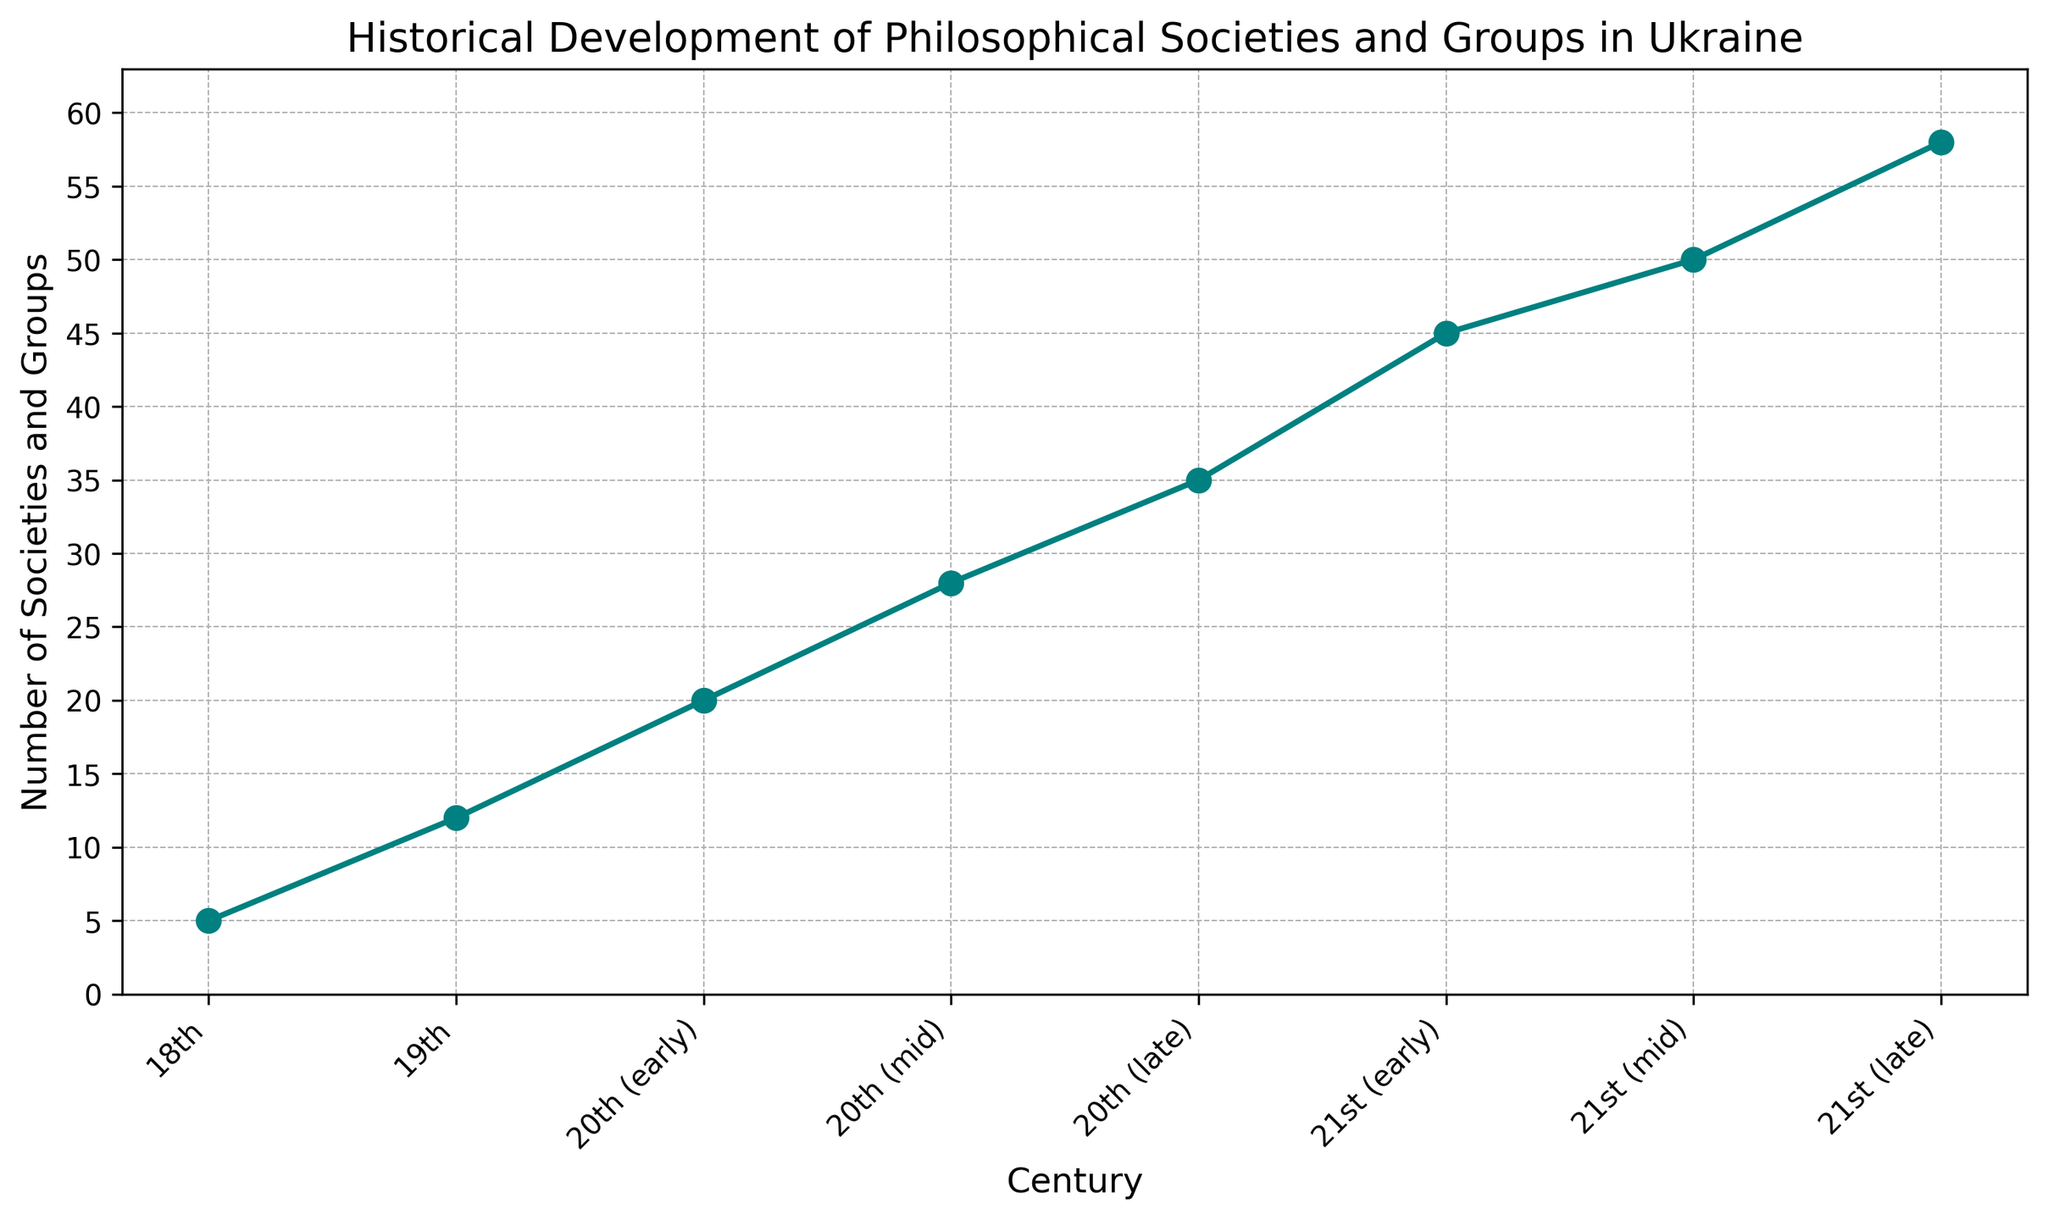How many more philosophical societies and groups were there in the 21st (early) century compared to the 18th century? First, find the number of societies in the 21st (early) century, which is 45. Then, find the number in the 18th century, which is 5. Subtract 5 from 45 to get the difference.
Answer: 40 Between which two consecutive centuries did the number of philosophical societies and groups increase the most? Calculate the difference in the number of societies between each consecutive pair of centuries: 
  
   - 18th to 19th: 12 - 5 = 7
   - 19th to 20th (early): 20 - 12 = 8
   - 20th (early) to 20th (mid): 28 - 20 = 8
   - 20th (mid) to 20th (late): 35 - 28 = 7
   - 20th (late) to 21st (early): 45 - 35 = 10
   - 21st (early) to 21st (mid): 50 - 45 = 5
   - 21st (mid) to 21st (late): 58 - 50 = 8
  
  The largest increase of 10 occurs from the 20th (late) to the 21st (early) century.
Answer: 20th (late) to 21st (early) What is the average number of philosophical societies and groups from the 18th century to the 21st (late) century? Sum the number of societies across all the centuries, which is 5 + 12 + 20 + 28 + 35 + 45 + 50 + 58 = 253. Then divide by the number of centuries, which is 8.
Answer: 31.625 How does the number of philosophical societies and groups in the 19th century compare to the 20th (early) century? In the 19th century, the number of societies is 12, and in the 20th (early) century, it is 20. Compare the two by finding the difference, 20 - 12 = 8.
Answer: 8 fewer in the 19th century Which century saw the smallest increase in the number of philosophical societies and groups compared to the previous century? Calculate the increases for each consecutive pair: 
  
   - 18th to 19th: 12 - 5 = 7
   - 19th to 20th (early): 20 - 12 = 8
   - 20th (early) to 20th (mid): 28 - 20 = 8
   - 20th (mid) to 20th (late): 35 - 28 = 7
   - 20th (late) to 21st (early): 45 - 35 = 10
   - 21st (early) to 21st (mid): 50 - 45 = 5
   - 21st (mid) to 21st (late): 58 - 50 = 8
  
  The smallest increase of 5 occurs from the 21st (early) to the 21st (mid) century.
Answer: 21st (early) to 21st (mid) What trends can you observe in the number of philosophical societies and groups in Ukraine over time? The chart shows a general upward trend with periodic increases in the number of societies and groups in every subsequent century. This trend accelerates significantly in the 20th and 21st centuries, with each following interval showing notable increases.
Answer: Upward trend, accelerating in the 20th and 21st centuries Among the data points, which century had the highest number of philosophical societies and groups and what is that number? Locate the highest point on the chart, at the 21st (late) century, showing 58 societies and groups.
Answer: 21st (late), 58 